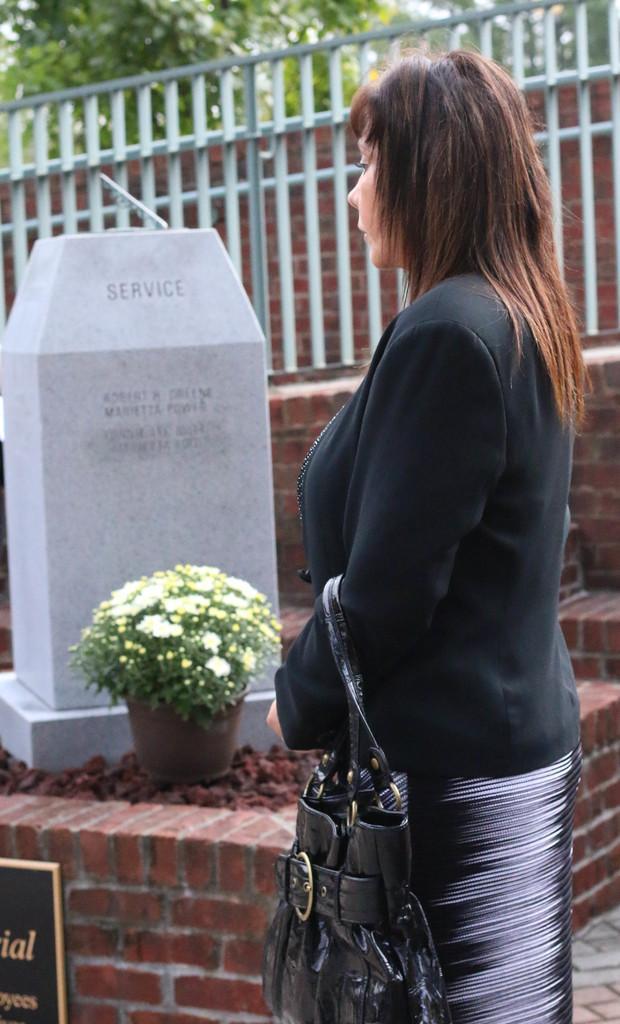In one or two sentences, can you explain what this image depicts? In this image, we can see a lady holding bag and in the background, there is a flower pot and there is a wall and we can see a fence. 